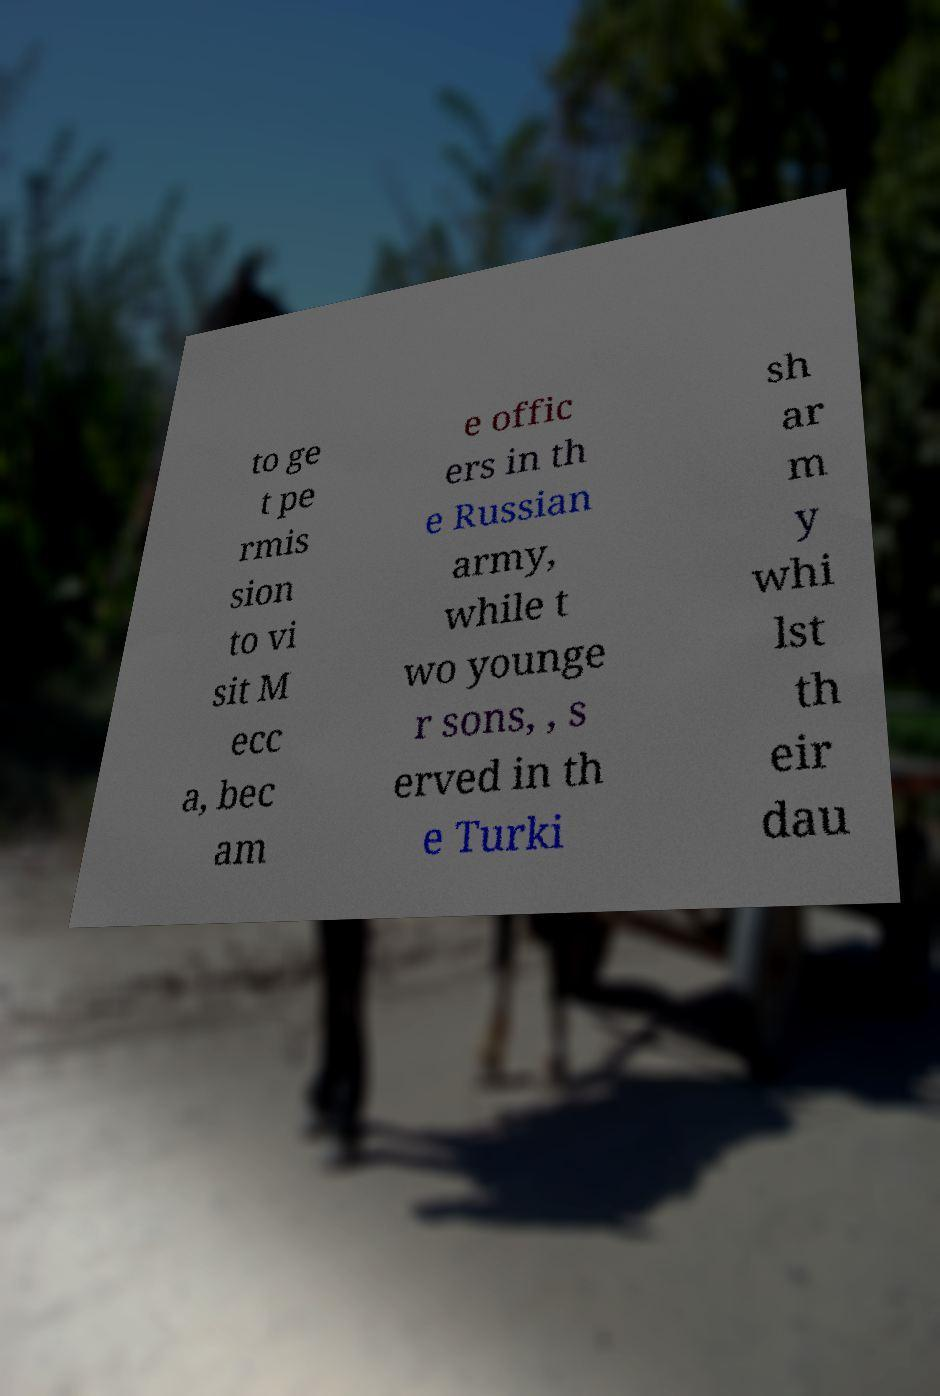Could you assist in decoding the text presented in this image and type it out clearly? to ge t pe rmis sion to vi sit M ecc a, bec am e offic ers in th e Russian army, while t wo younge r sons, , s erved in th e Turki sh ar m y whi lst th eir dau 